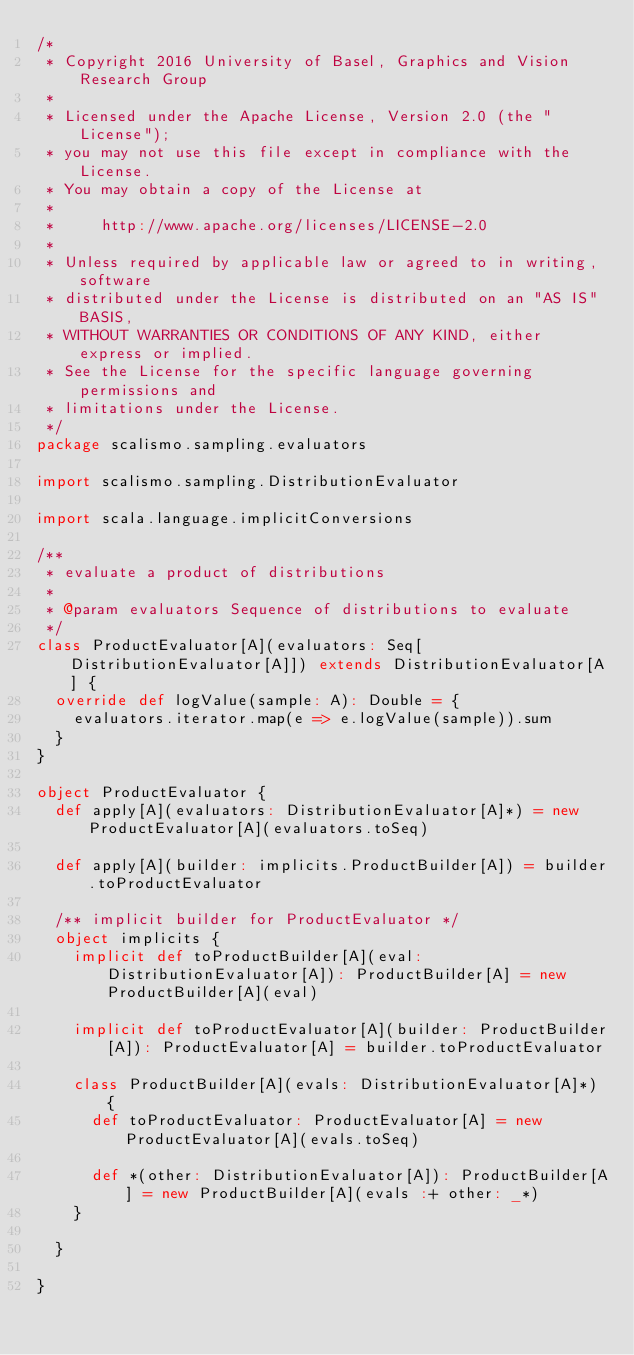Convert code to text. <code><loc_0><loc_0><loc_500><loc_500><_Scala_>/*
 * Copyright 2016 University of Basel, Graphics and Vision Research Group
 *
 * Licensed under the Apache License, Version 2.0 (the "License");
 * you may not use this file except in compliance with the License.
 * You may obtain a copy of the License at
 *
 *     http://www.apache.org/licenses/LICENSE-2.0
 *
 * Unless required by applicable law or agreed to in writing, software
 * distributed under the License is distributed on an "AS IS" BASIS,
 * WITHOUT WARRANTIES OR CONDITIONS OF ANY KIND, either express or implied.
 * See the License for the specific language governing permissions and
 * limitations under the License.
 */
package scalismo.sampling.evaluators

import scalismo.sampling.DistributionEvaluator

import scala.language.implicitConversions

/**
 * evaluate a product of distributions
 *
 * @param evaluators Sequence of distributions to evaluate
 */
class ProductEvaluator[A](evaluators: Seq[DistributionEvaluator[A]]) extends DistributionEvaluator[A] {
  override def logValue(sample: A): Double = {
    evaluators.iterator.map(e => e.logValue(sample)).sum
  }
}

object ProductEvaluator {
  def apply[A](evaluators: DistributionEvaluator[A]*) = new ProductEvaluator[A](evaluators.toSeq)

  def apply[A](builder: implicits.ProductBuilder[A]) = builder.toProductEvaluator

  /** implicit builder for ProductEvaluator */
  object implicits {
    implicit def toProductBuilder[A](eval: DistributionEvaluator[A]): ProductBuilder[A] = new ProductBuilder[A](eval)

    implicit def toProductEvaluator[A](builder: ProductBuilder[A]): ProductEvaluator[A] = builder.toProductEvaluator

    class ProductBuilder[A](evals: DistributionEvaluator[A]*) {
      def toProductEvaluator: ProductEvaluator[A] = new ProductEvaluator[A](evals.toSeq)

      def *(other: DistributionEvaluator[A]): ProductBuilder[A] = new ProductBuilder[A](evals :+ other: _*)
    }

  }

}
</code> 